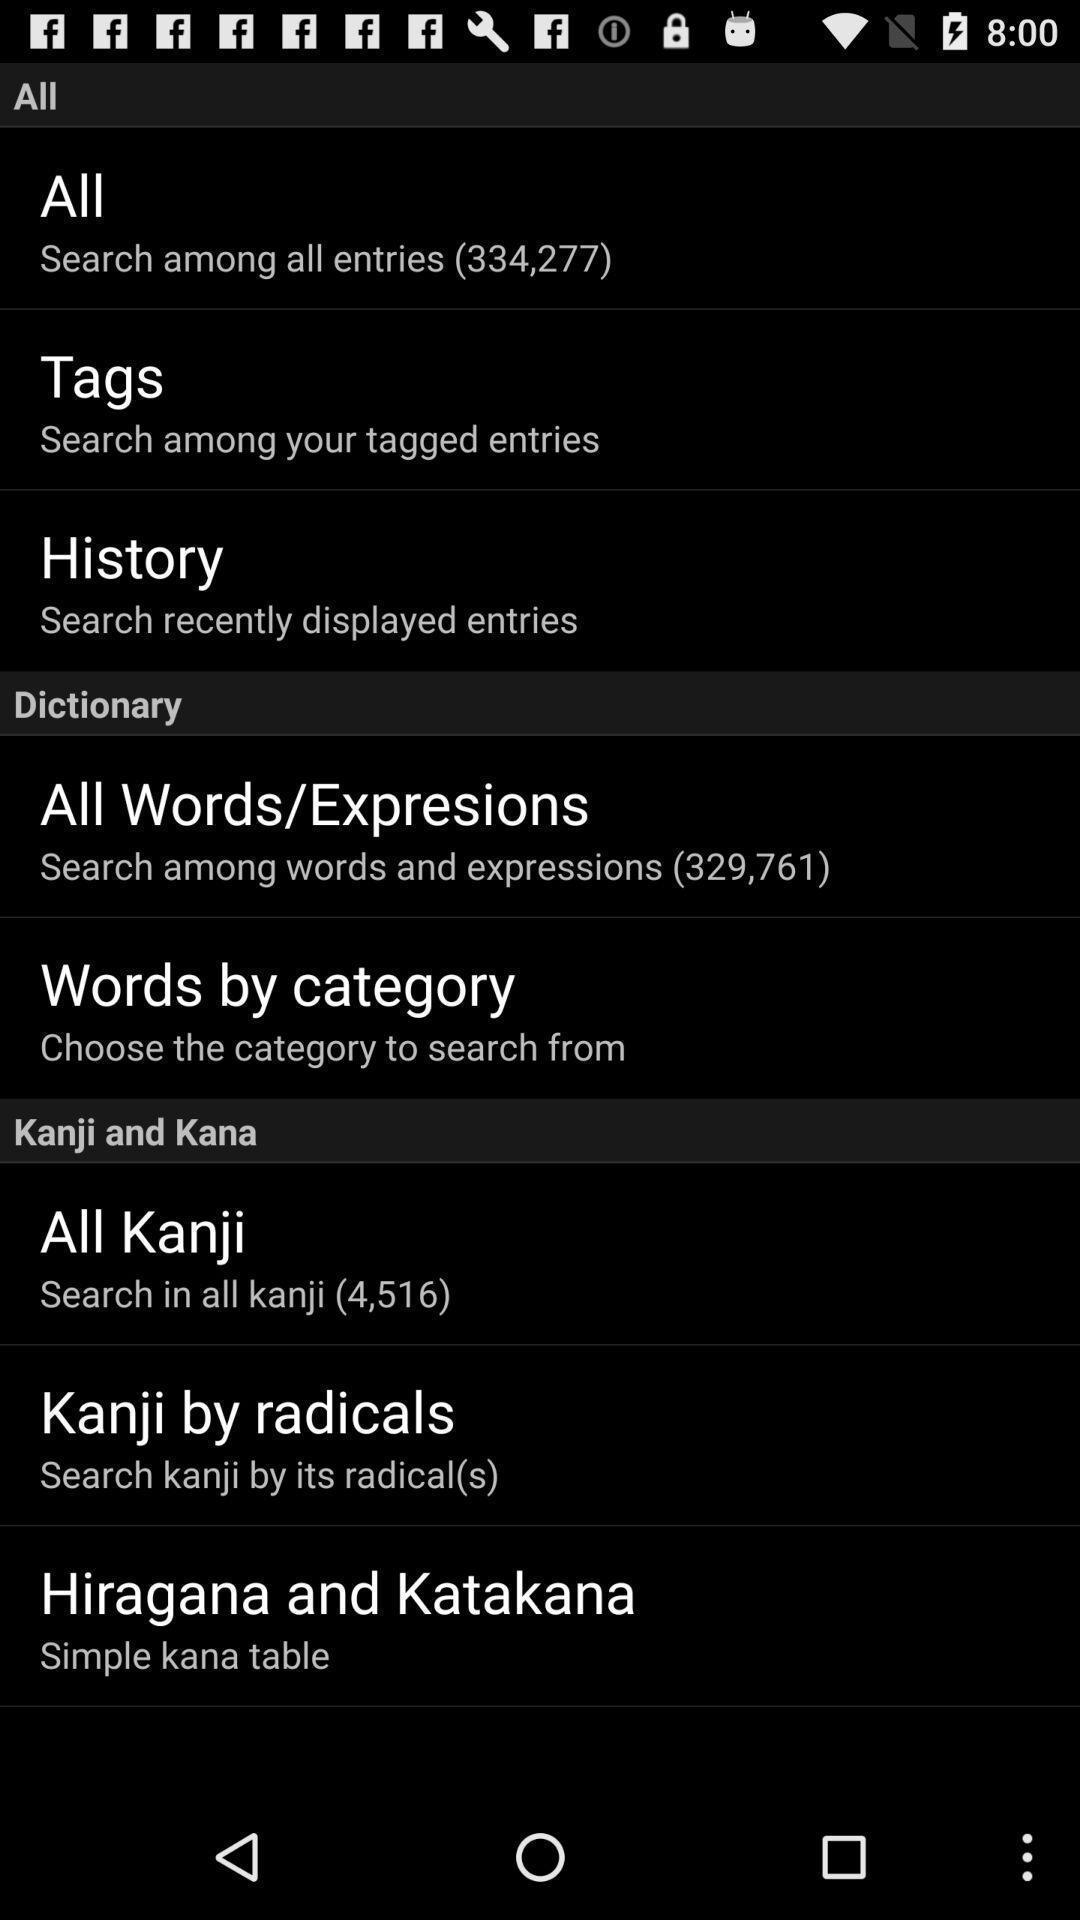Provide a detailed account of this screenshot. Screen shows settings options in the dictionary app. 